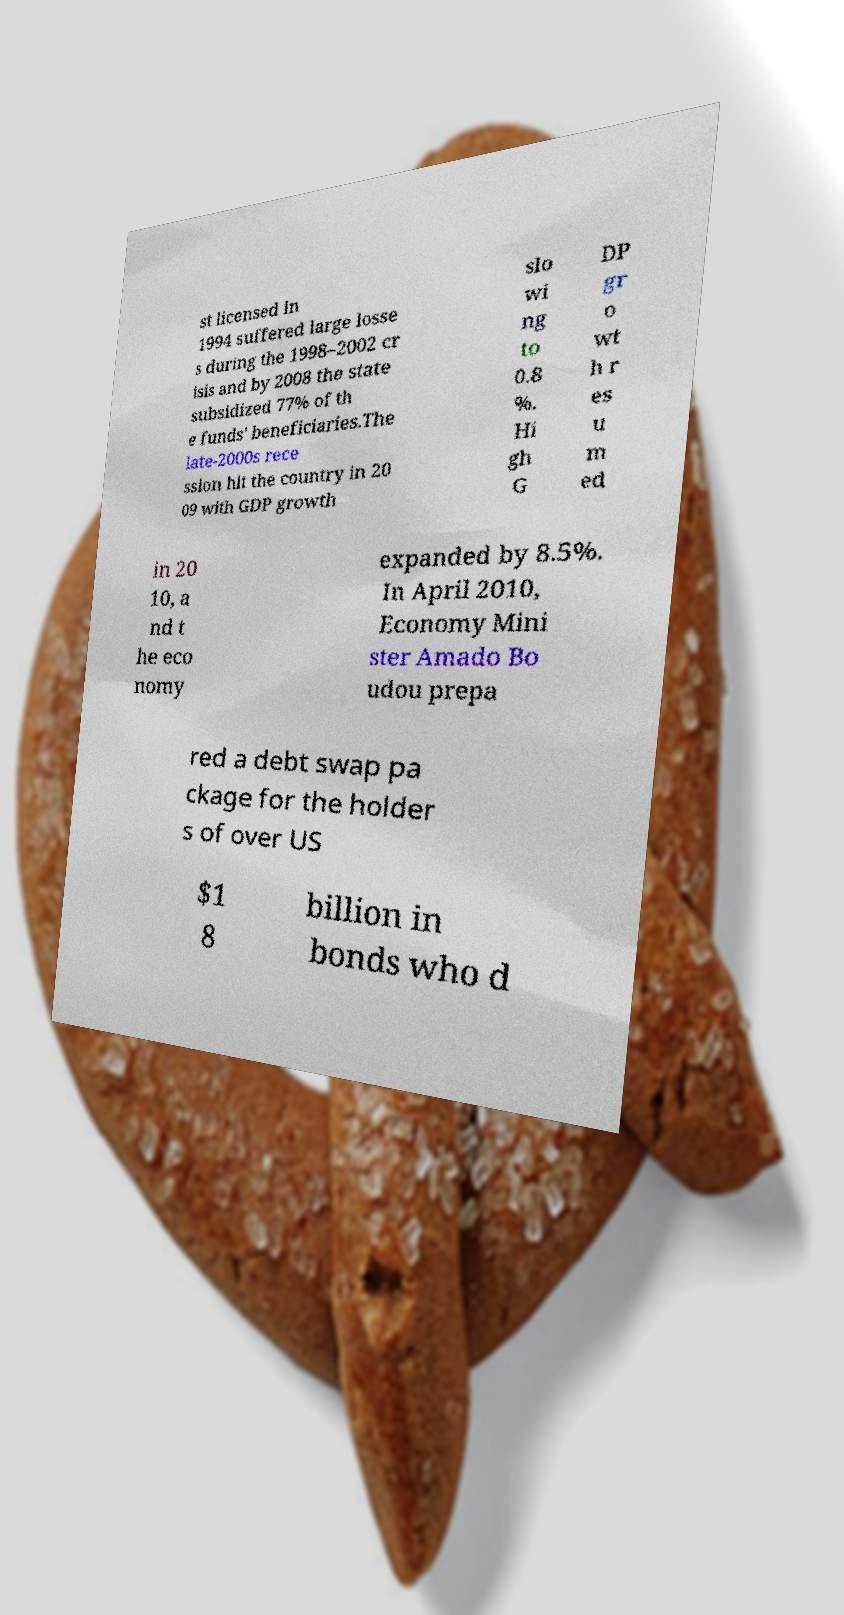There's text embedded in this image that I need extracted. Can you transcribe it verbatim? st licensed in 1994 suffered large losse s during the 1998–2002 cr isis and by 2008 the state subsidized 77% of th e funds' beneficiaries.The late-2000s rece ssion hit the country in 20 09 with GDP growth slo wi ng to 0.8 %. Hi gh G DP gr o wt h r es u m ed in 20 10, a nd t he eco nomy expanded by 8.5%. In April 2010, Economy Mini ster Amado Bo udou prepa red a debt swap pa ckage for the holder s of over US $1 8 billion in bonds who d 